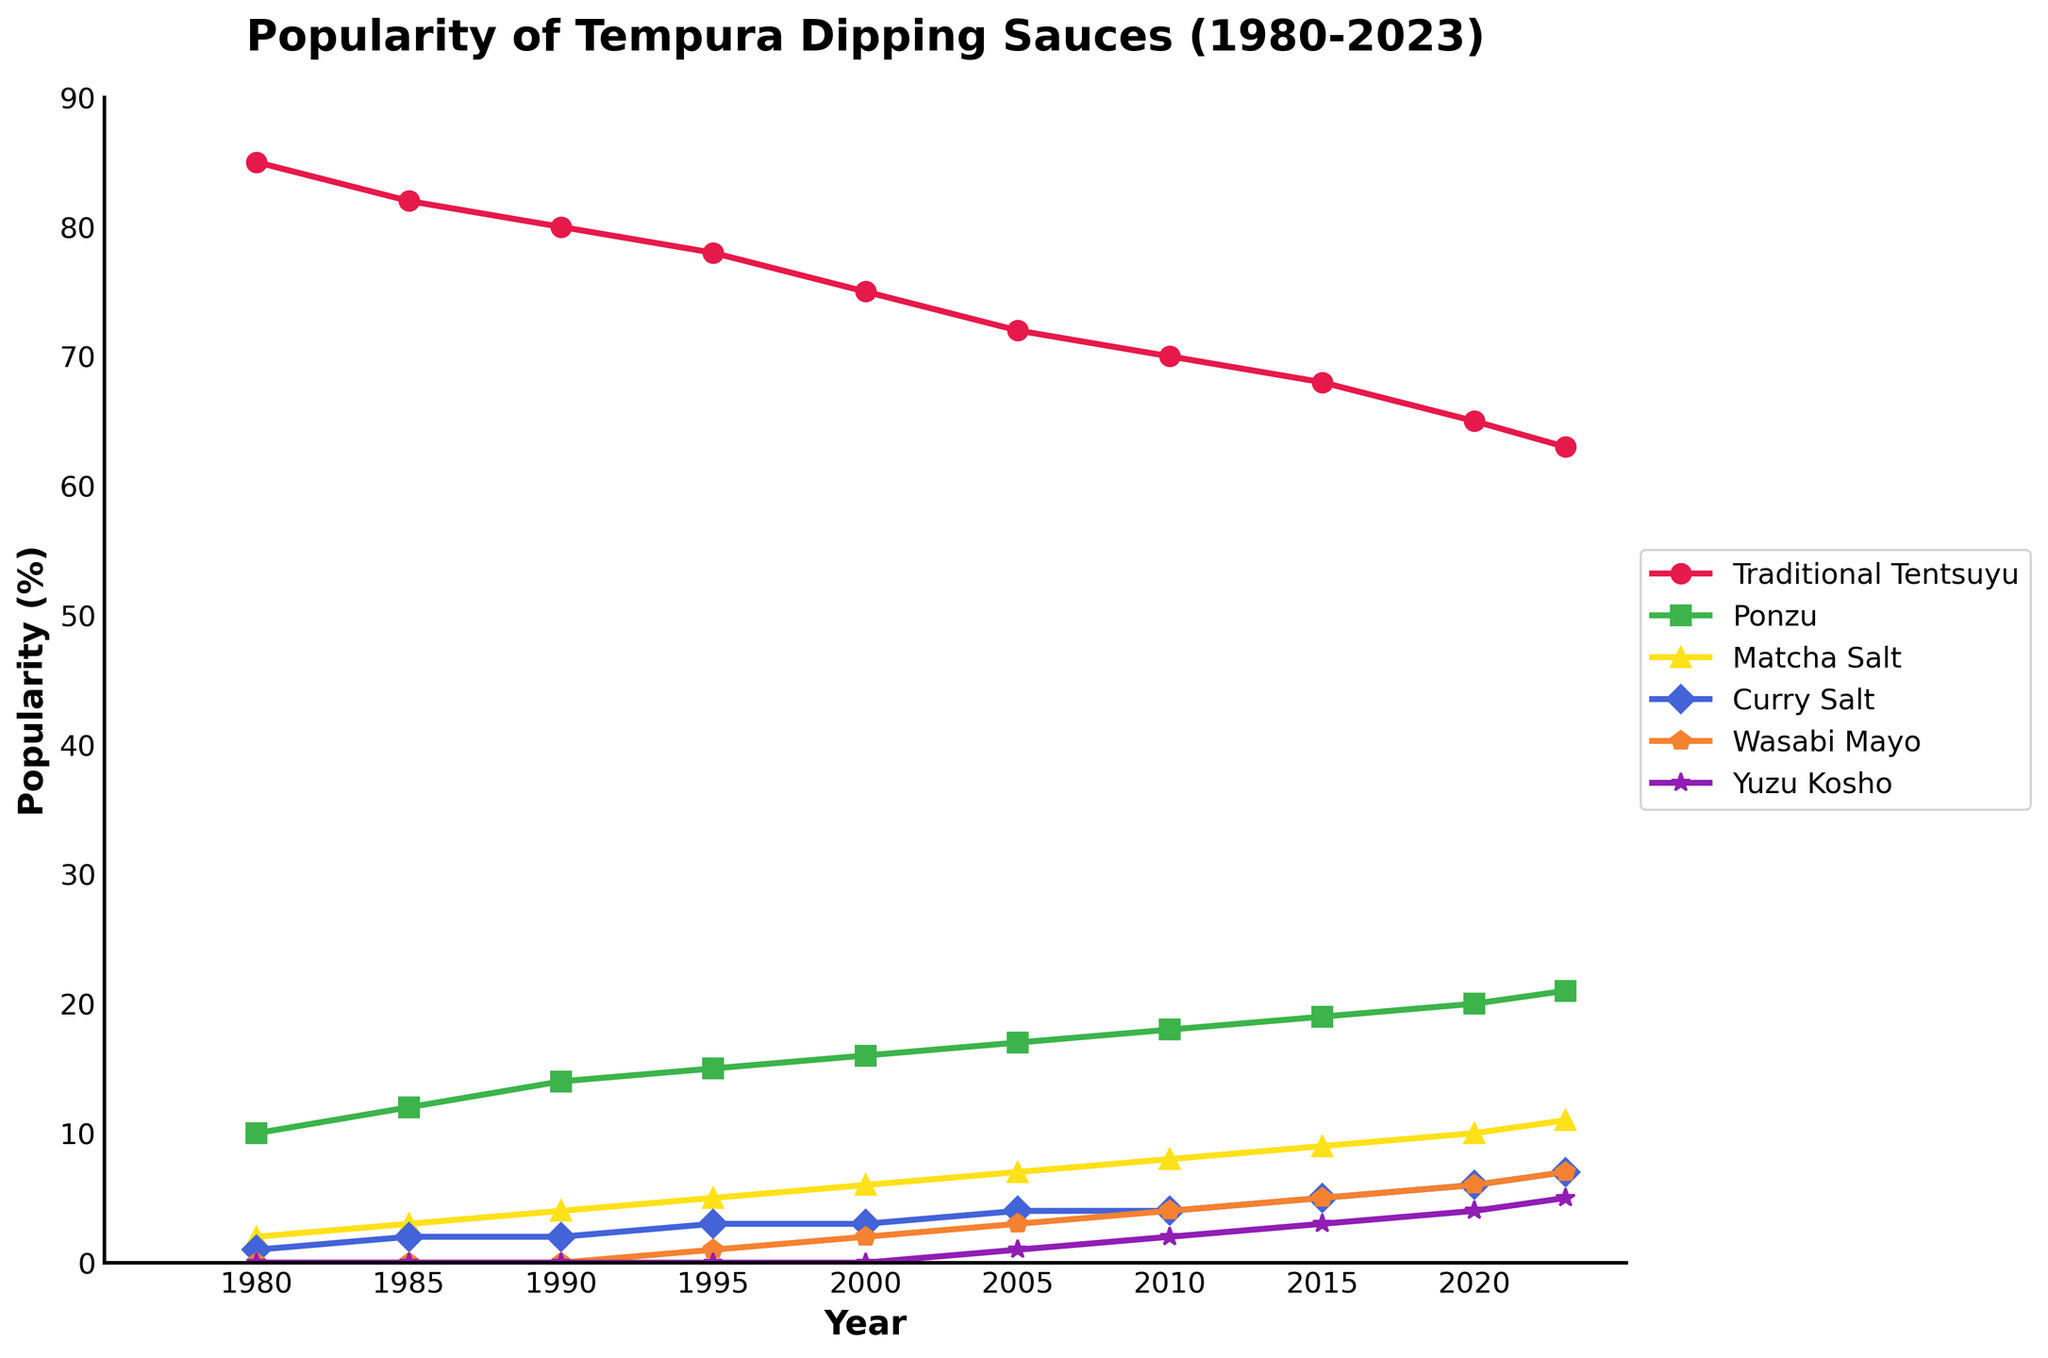Which year did Wasabi Mayo first appear in the chart? By examining the data points, we see that Wasabi Mayo's popularity is greater than 0 for the first time in 1995.
Answer: 1995 What is the change in popularity of Traditional Tentsuyu from 1980 to 2023? In 1980, Traditional Tentsuyu has a popularity of 85%. By 2023, it has decreased to 63%. The change is calculated as 63 - 85 = -22.
Answer: -22 What is the sum of the popularity percentages of Ponzu and Matcha Salt in 2020? In 2020, Ponzu has a popularity of 20% and Matcha Salt has 10%. Adding these values gives 20 + 10 = 30.
Answer: 30 Between which years did Yuzu Kosho see the fastest increase in popularity? The steepest increase in the line for Yuzu Kosho occurs between 2015 and 2020, going from a popularity of 3% to 4%, which is an increase of 1% over 5 years.
Answer: 2015 - 2020 What is the average popularity of Curry Salt over the entire period? Add the popularity percentages of Curry Salt for all years and divide by the number of years: (1 + 2 + 2 + 3 + 3 + 4 + 4 + 5 + 6 + 7) / 10 = 3.7.
Answer: 3.7 In which year did Ponzu surpass the 15% popularity mark? Ponzu first exceeds 15% in 2000 with a popularity of 16%.
Answer: 2000 How does the popularity change of Ponzu from 1980 to 2023 compare to Traditional Tentsuyu over the same period? Ponzu increased from 10% to 21%, resulting in a change of 21 - 10 = 11. Traditional Tentsuyu decreased from 85% to 63%, resulting in a change of 63 - 85 = -22. So, Ponzu increased by 11, while Traditional Tentsuyu decreased by 22.
Answer: Ponzu: +11, Tentsuyu: -22 Which dipping sauce experienced the most significant increase in the last decade (2013-2023)? Compare all sauces' popularity changes between 2013 and 2023: Traditional Tentsuyu decreased from 68% to 63%, Ponzu increased from 19% to 21%, Matcha Salt increased from 9% to 11%, Curry Salt increased from 5% to 7%, Wasabi Mayo increased from 5% to 7%, and Yuzu Kosho increased from 3% to 5%. The most significant increase is 2% for Curry Salt.
Answer: Curry Salt What is the color and marker style used to represent Ponzu in the chart? Ponzu is represented with a green color and a square marker style.
Answer: Green, square 